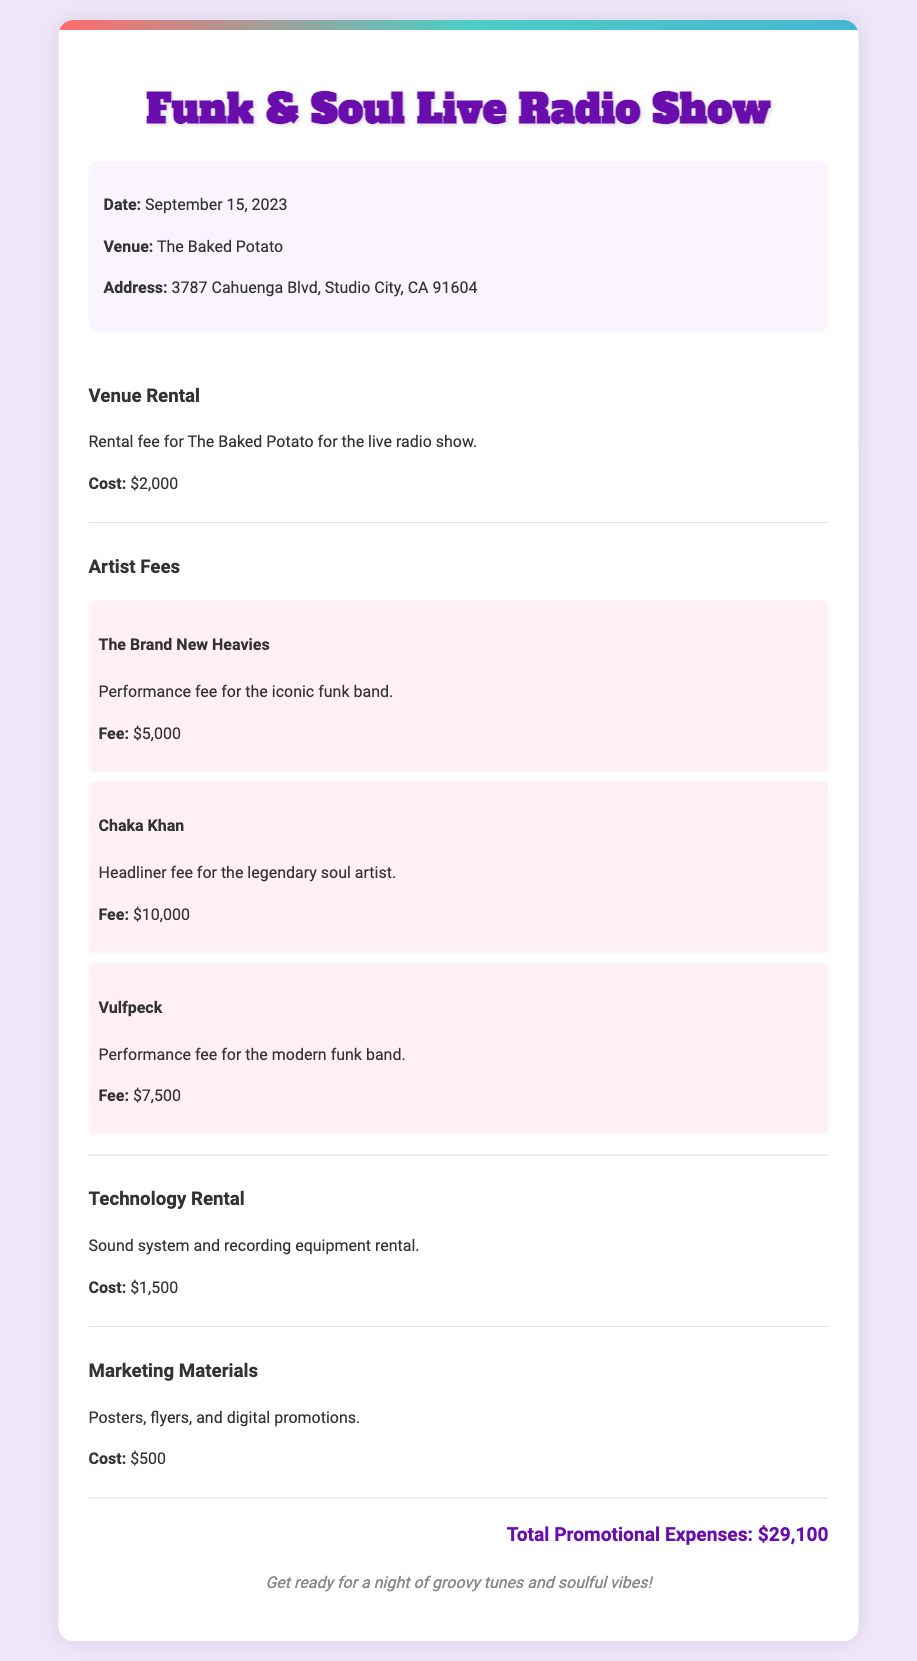What is the date of the event? The date of the event is specified within the event details section of the document.
Answer: September 15, 2023 What is the venue of the live radio show? The venue is mentioned in the event details section, identifying the location of the show.
Answer: The Baked Potato How much is the artist fee for Chaka Khan? The fee for Chaka Khan is directly stated under the artist fees section, specifically for that artist.
Answer: $10,000 What is the total cost for venue rental? The venue rental cost is detailed in the expense item for venue rental within the document.
Answer: $2,000 What is the total promotional expenses? The total promotional expenses are calculated and displayed at the end of the document summarizing all expenses.
Answer: $29,100 How many artists are listed in the expense section? The number of artists can be counted from the artist fees subsection in the document.
Answer: 3 What type of event is being held? The type of event is described in the title of the document highlighting its focus.
Answer: Live Radio Show What is included in the marketing materials expense? The document specifies what marketing materials entail in the corresponding expense section.
Answer: Posters, flyers, and digital promotions How much does technology rental cost? The cost for technology rental is explicitly provided in the expense item related to technology.
Answer: $1,500 